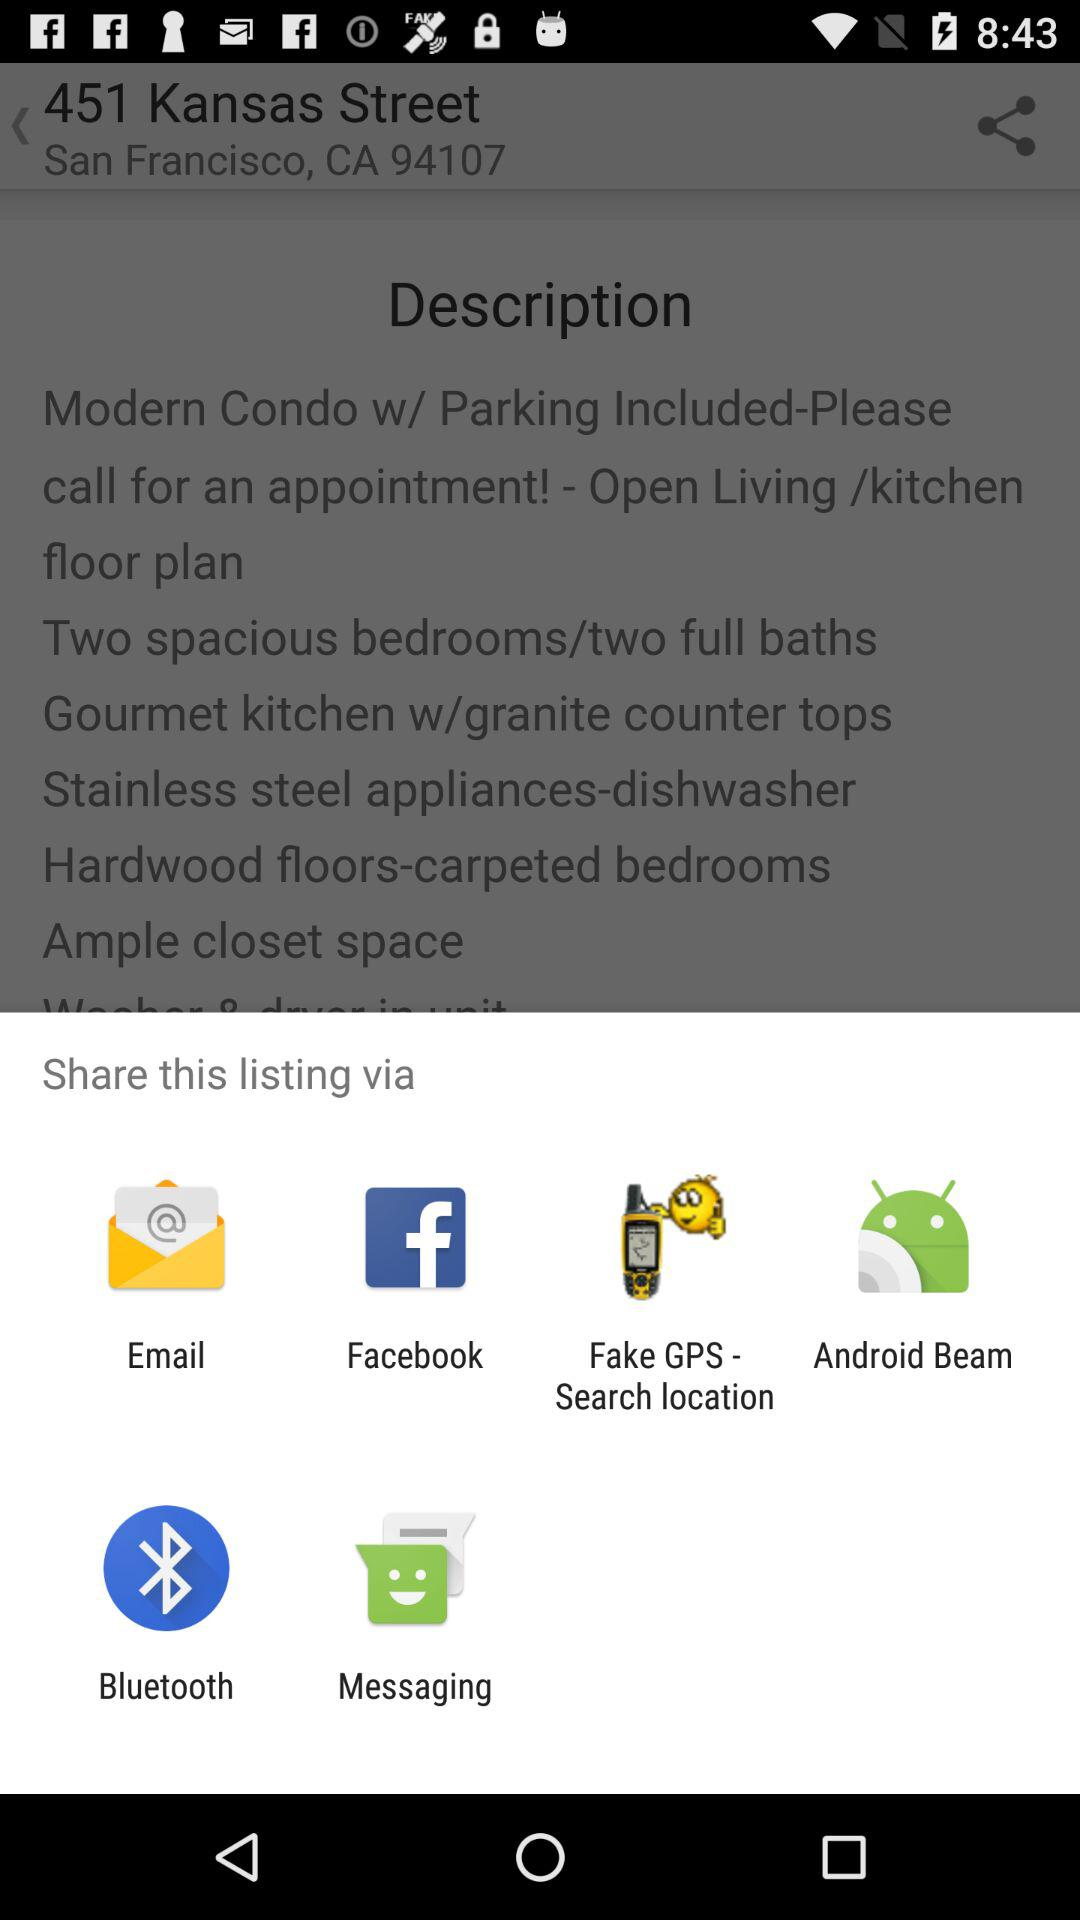How many share options are there?
Answer the question using a single word or phrase. 6 